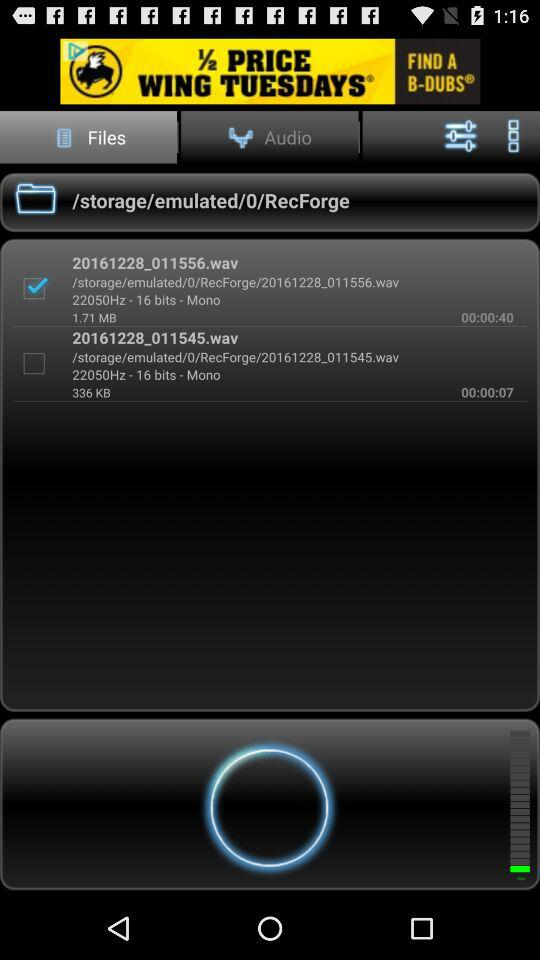What is the size of the smaller audio file?
Answer the question using a single word or phrase. 336 KB 